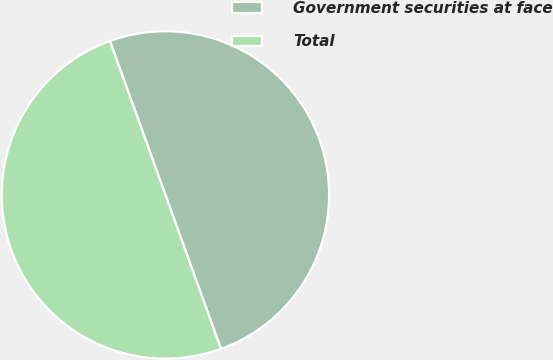Convert chart to OTSL. <chart><loc_0><loc_0><loc_500><loc_500><pie_chart><fcel>Government securities at face<fcel>Total<nl><fcel>50.0%<fcel>50.0%<nl></chart> 